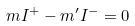Convert formula to latex. <formula><loc_0><loc_0><loc_500><loc_500>m I ^ { + } - m ^ { \prime } I ^ { - } = 0</formula> 